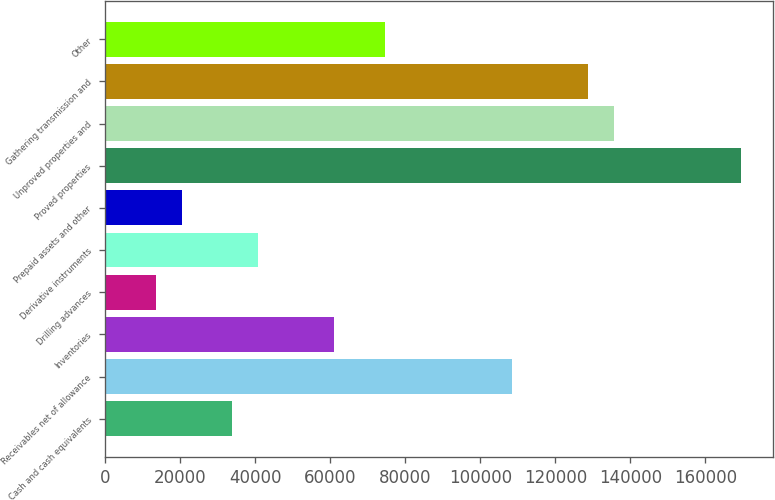<chart> <loc_0><loc_0><loc_500><loc_500><bar_chart><fcel>Cash and cash equivalents<fcel>Receivables net of allowance<fcel>Inventories<fcel>Drilling advances<fcel>Derivative instruments<fcel>Prepaid assets and other<fcel>Proved properties<fcel>Unproved properties and<fcel>Gathering transmission and<fcel>Other<nl><fcel>33907<fcel>108483<fcel>61025.4<fcel>13568.2<fcel>40686.6<fcel>20347.8<fcel>169499<fcel>135601<fcel>128821<fcel>74584.6<nl></chart> 